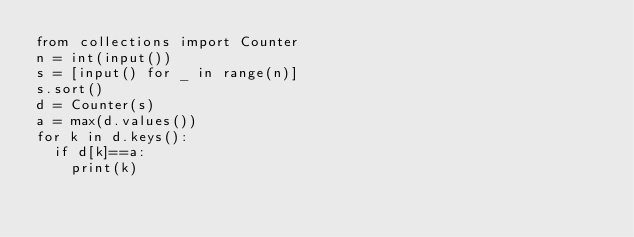<code> <loc_0><loc_0><loc_500><loc_500><_Python_>from collections import Counter
n = int(input())
s = [input() for _ in range(n)]
s.sort()
d = Counter(s)
a = max(d.values())
for k in d.keys():
  if d[k]==a:
    print(k)</code> 